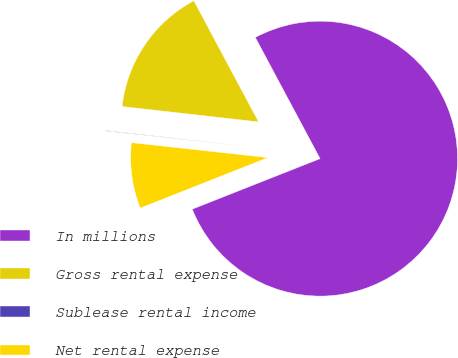<chart> <loc_0><loc_0><loc_500><loc_500><pie_chart><fcel>In millions<fcel>Gross rental expense<fcel>Sublease rental income<fcel>Net rental expense<nl><fcel>76.82%<fcel>15.4%<fcel>0.05%<fcel>7.73%<nl></chart> 